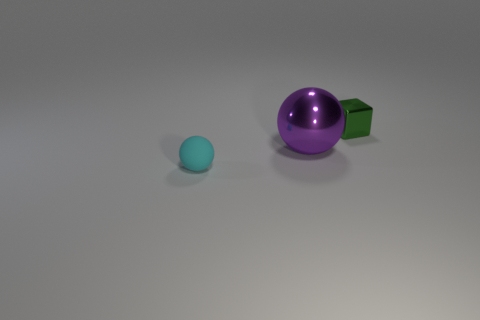What number of tiny gray matte objects are the same shape as the big purple metallic object?
Make the answer very short. 0. How many things are both on the right side of the large shiny sphere and on the left side of the purple shiny thing?
Offer a terse response. 0. What is the color of the metallic block?
Ensure brevity in your answer.  Green. Are there any tiny cubes that have the same material as the big purple thing?
Offer a terse response. Yes. There is a small thing behind the small object that is in front of the tiny green block; is there a purple object in front of it?
Provide a short and direct response. Yes. Are there any balls left of the large metal object?
Give a very brief answer. Yes. How many large objects are cylinders or shiny things?
Provide a short and direct response. 1. Is the material of the tiny object that is on the right side of the big metallic object the same as the big purple thing?
Make the answer very short. Yes. There is a small object that is on the right side of the small thing to the left of the ball that is behind the tiny matte object; what is its shape?
Make the answer very short. Cube. How many blue objects are small spheres or tiny metallic blocks?
Your answer should be very brief. 0. 